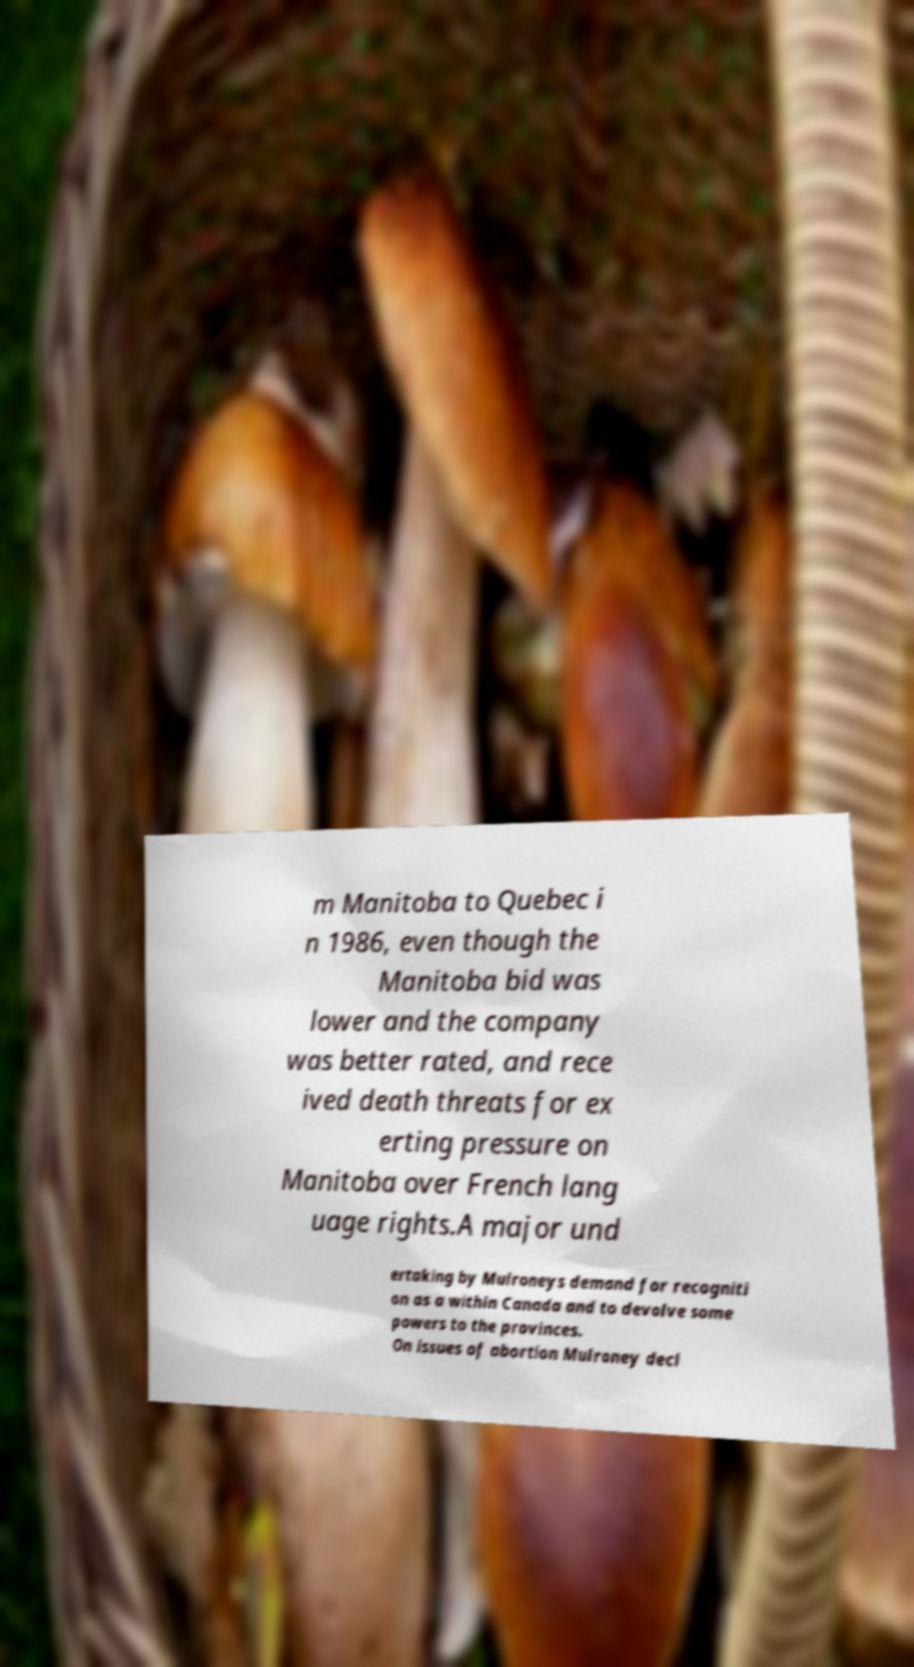Can you read and provide the text displayed in the image?This photo seems to have some interesting text. Can you extract and type it out for me? m Manitoba to Quebec i n 1986, even though the Manitoba bid was lower and the company was better rated, and rece ived death threats for ex erting pressure on Manitoba over French lang uage rights.A major und ertaking by Mulroneys demand for recogniti on as a within Canada and to devolve some powers to the provinces. On issues of abortion Mulroney decl 